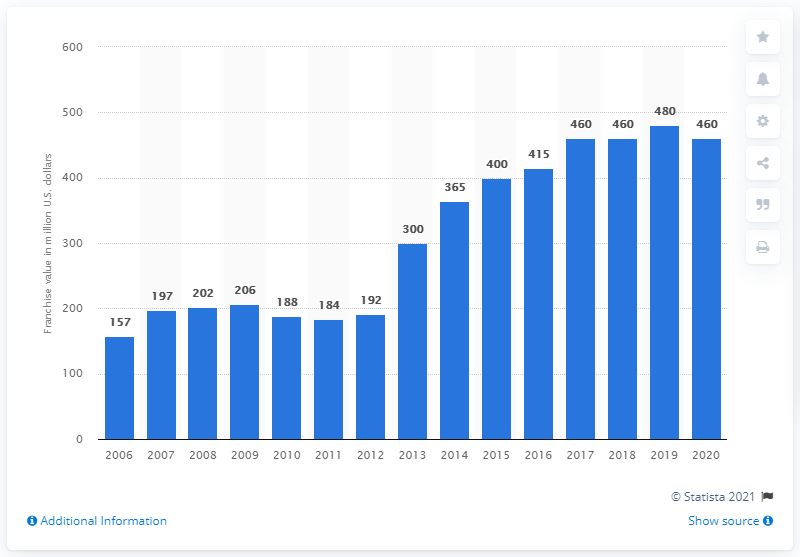Draw attention to some important aspects in this diagram. The value of the Anaheim Ducks franchise in 2020 was approximately 460 million dollars. 